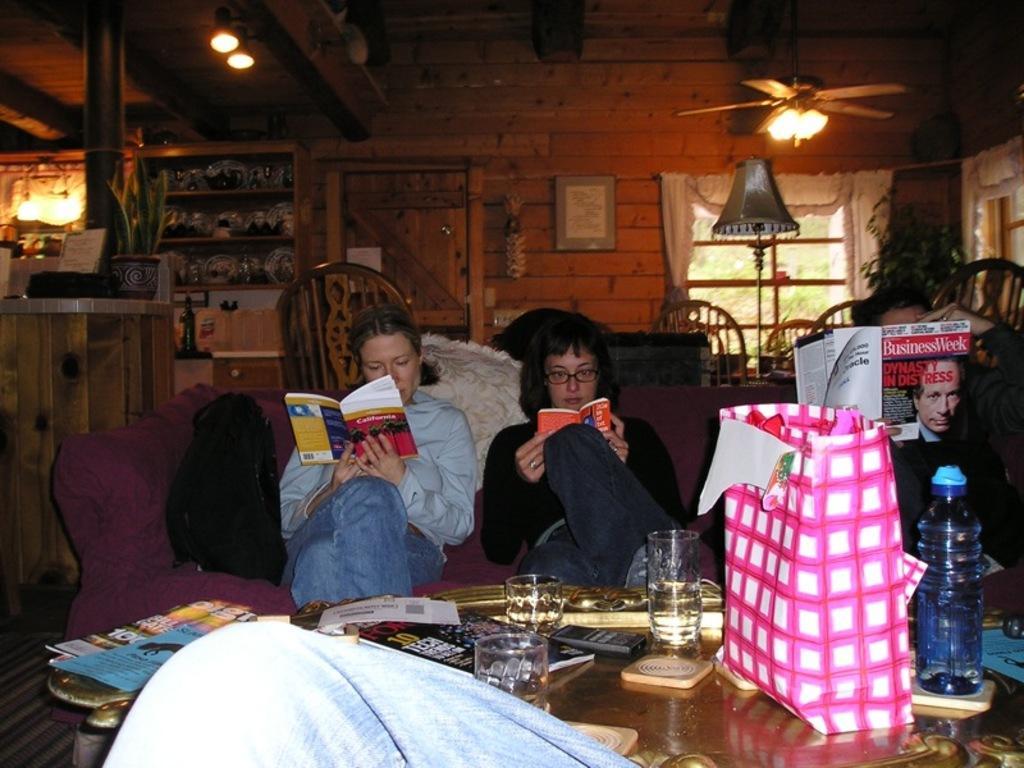In one or two sentences, can you explain what this image depicts? This picture describes about group of people, they are seated on the sofa and they are reading books, in front of them we can find few glasses, books, bag, bottle and other things on the table, in the background we can see a plant, few lights and a wall frame on the wall. 